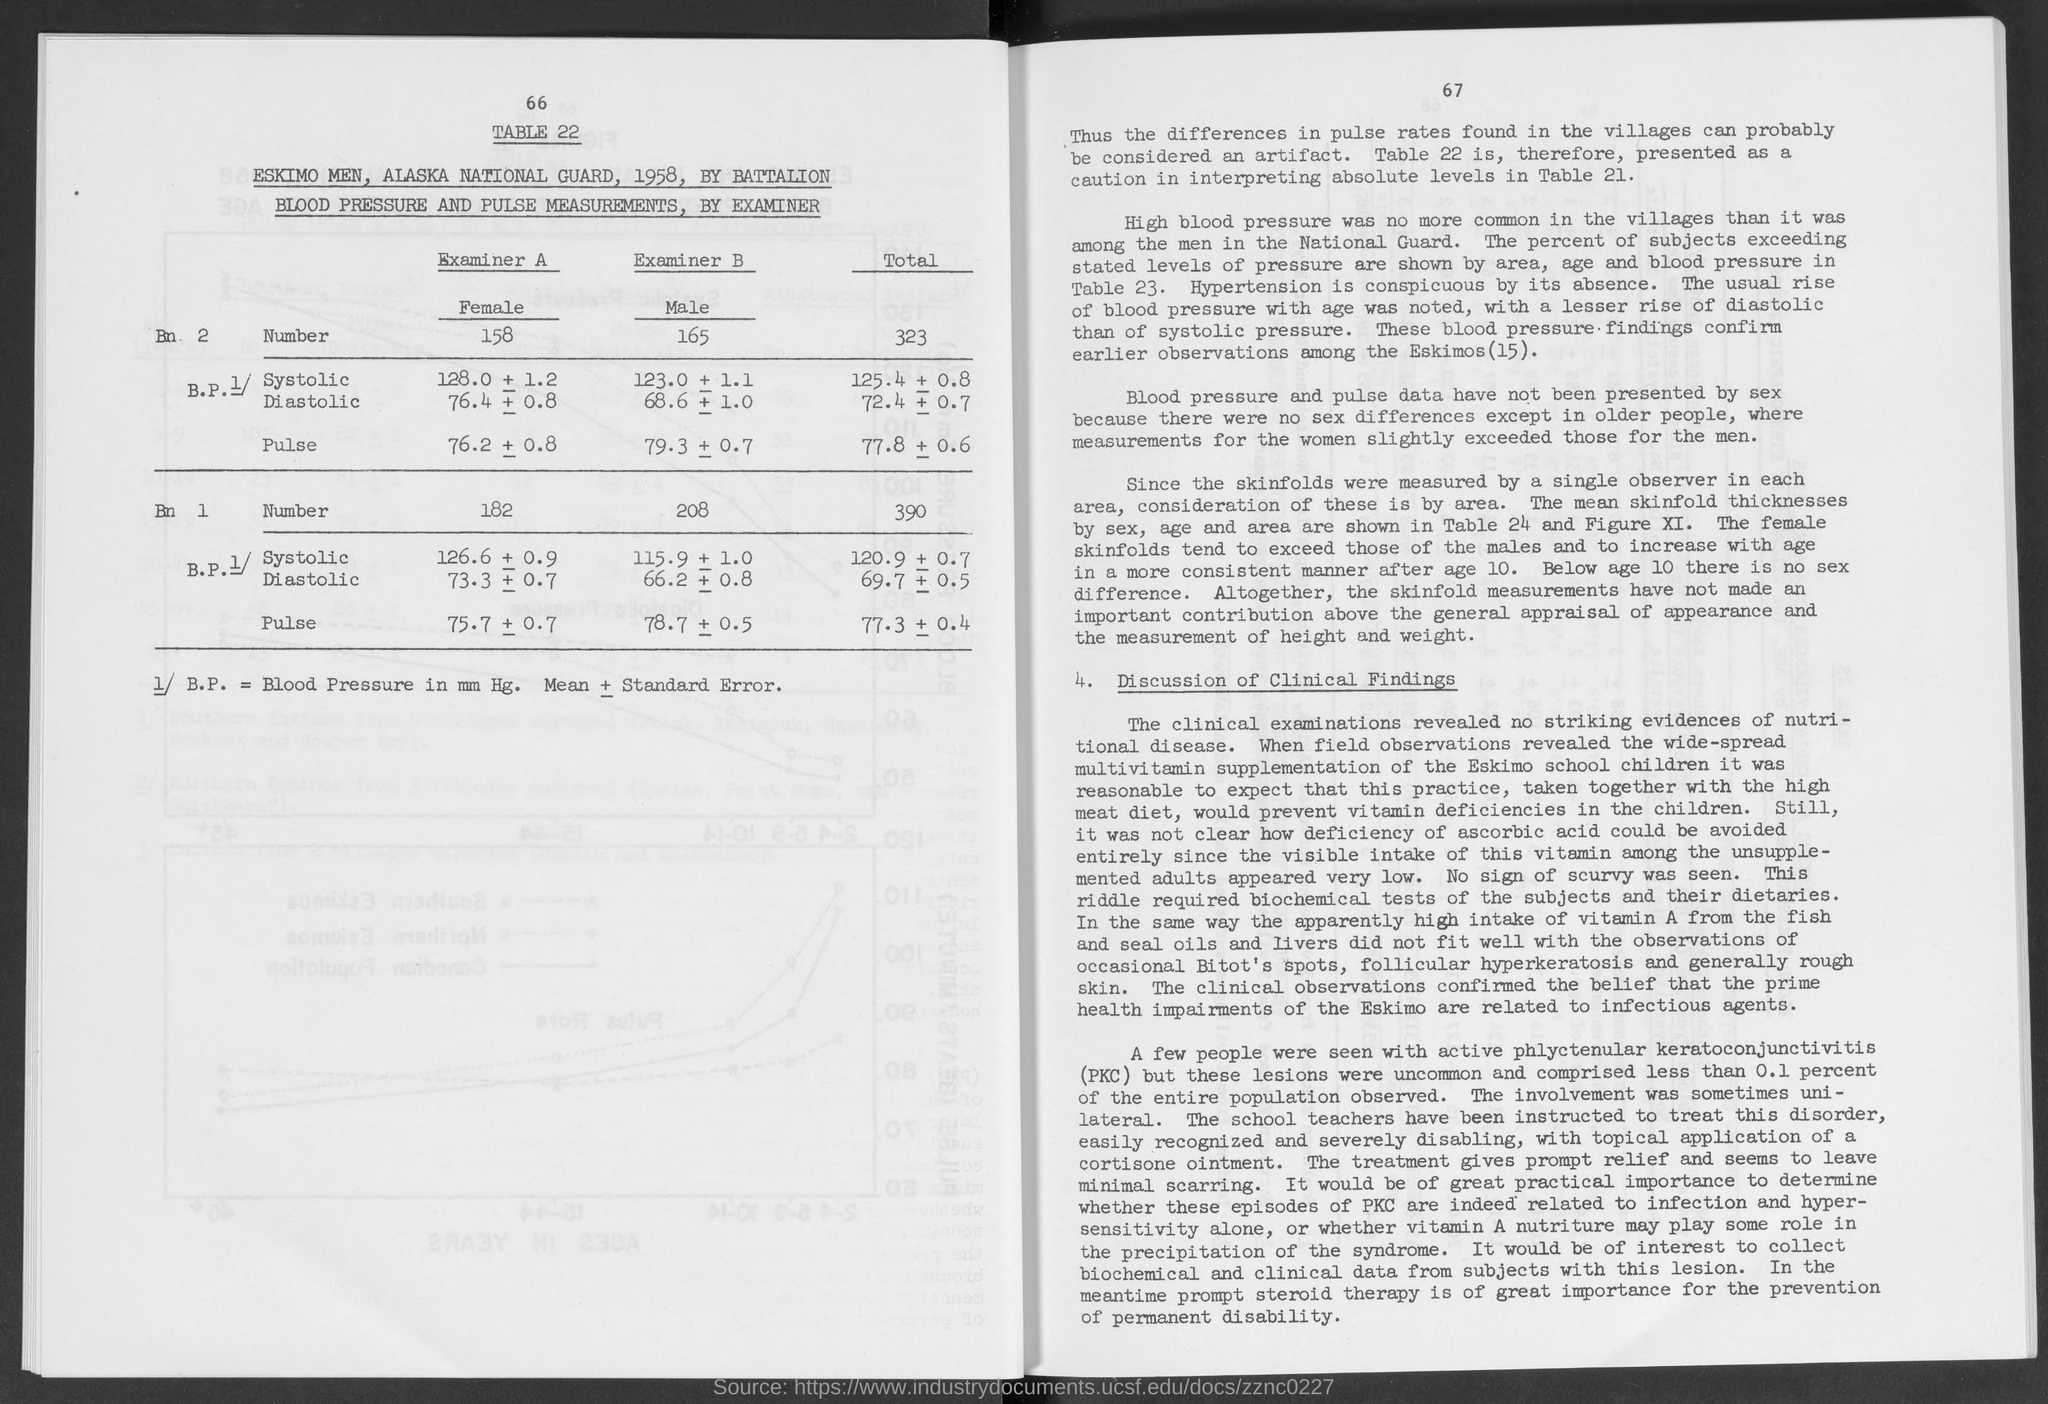Draw attention to some important aspects in this diagram. There are 182 females in Battalion 1. The number of males in battalion 1 is 208. The total number of members in Battalion 1 is 390. The table number is 22. The total number of members in Battalion 2 is 323. 